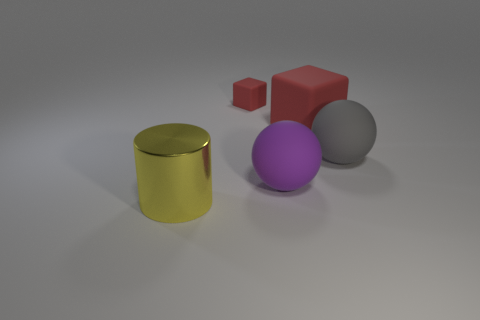How many other objects are the same color as the tiny block?
Offer a very short reply. 1. What is the color of the big metallic cylinder that is left of the small rubber object?
Provide a short and direct response. Yellow. Is there a gray thing that has the same size as the yellow metal thing?
Your answer should be very brief. Yes. There is a red object that is the same size as the yellow metal thing; what is its material?
Your answer should be compact. Rubber. How many things are objects that are behind the large yellow thing or red rubber blocks that are to the left of the purple rubber sphere?
Your answer should be very brief. 4. Is there a big yellow metal object that has the same shape as the purple thing?
Provide a succinct answer. No. There is a small cube that is the same color as the large block; what material is it?
Keep it short and to the point. Rubber. How many metallic things are large gray cylinders or big red blocks?
Keep it short and to the point. 0. What shape is the large red matte thing?
Keep it short and to the point. Cube. How many red objects are made of the same material as the big purple sphere?
Provide a succinct answer. 2. 